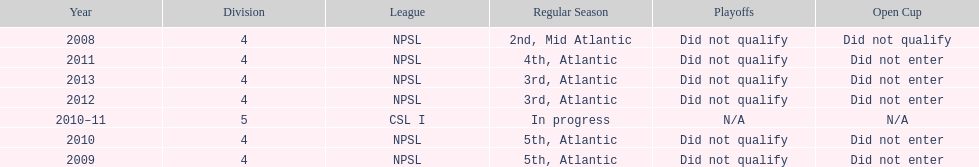Which year was more successful, 2010 or 2013? 2013. Could you parse the entire table as a dict? {'header': ['Year', 'Division', 'League', 'Regular Season', 'Playoffs', 'Open Cup'], 'rows': [['2008', '4', 'NPSL', '2nd, Mid Atlantic', 'Did not qualify', 'Did not qualify'], ['2011', '4', 'NPSL', '4th, Atlantic', 'Did not qualify', 'Did not enter'], ['2013', '4', 'NPSL', '3rd, Atlantic', 'Did not qualify', 'Did not enter'], ['2012', '4', 'NPSL', '3rd, Atlantic', 'Did not qualify', 'Did not enter'], ['2010–11', '5', 'CSL I', 'In progress', 'N/A', 'N/A'], ['2010', '4', 'NPSL', '5th, Atlantic', 'Did not qualify', 'Did not enter'], ['2009', '4', 'NPSL', '5th, Atlantic', 'Did not qualify', 'Did not enter']]} 